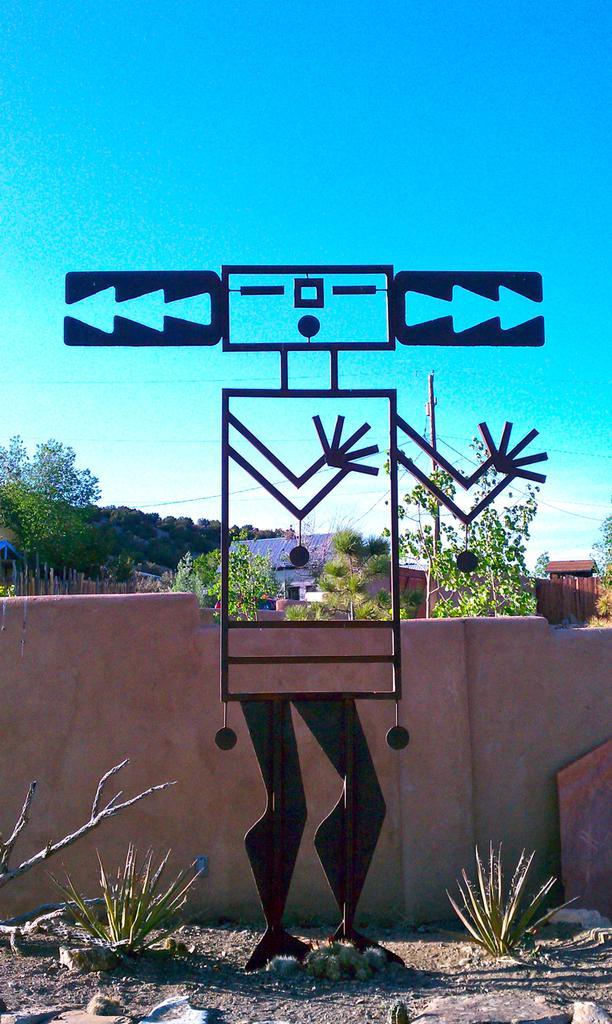Can you describe this image briefly? There is a metal object as we can see at the bottom of this image and there is a wall, trees and some buildings in the background. There is a sky at the top of this image. We can see some plants at the bottom of this image. 